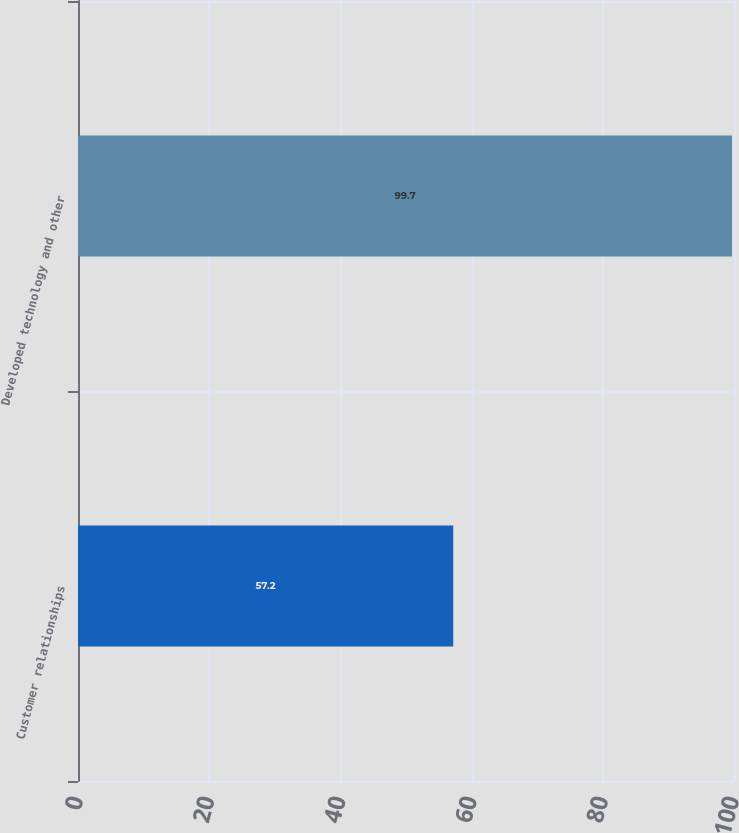Convert chart. <chart><loc_0><loc_0><loc_500><loc_500><bar_chart><fcel>Customer relationships<fcel>Developed technology and other<nl><fcel>57.2<fcel>99.7<nl></chart> 